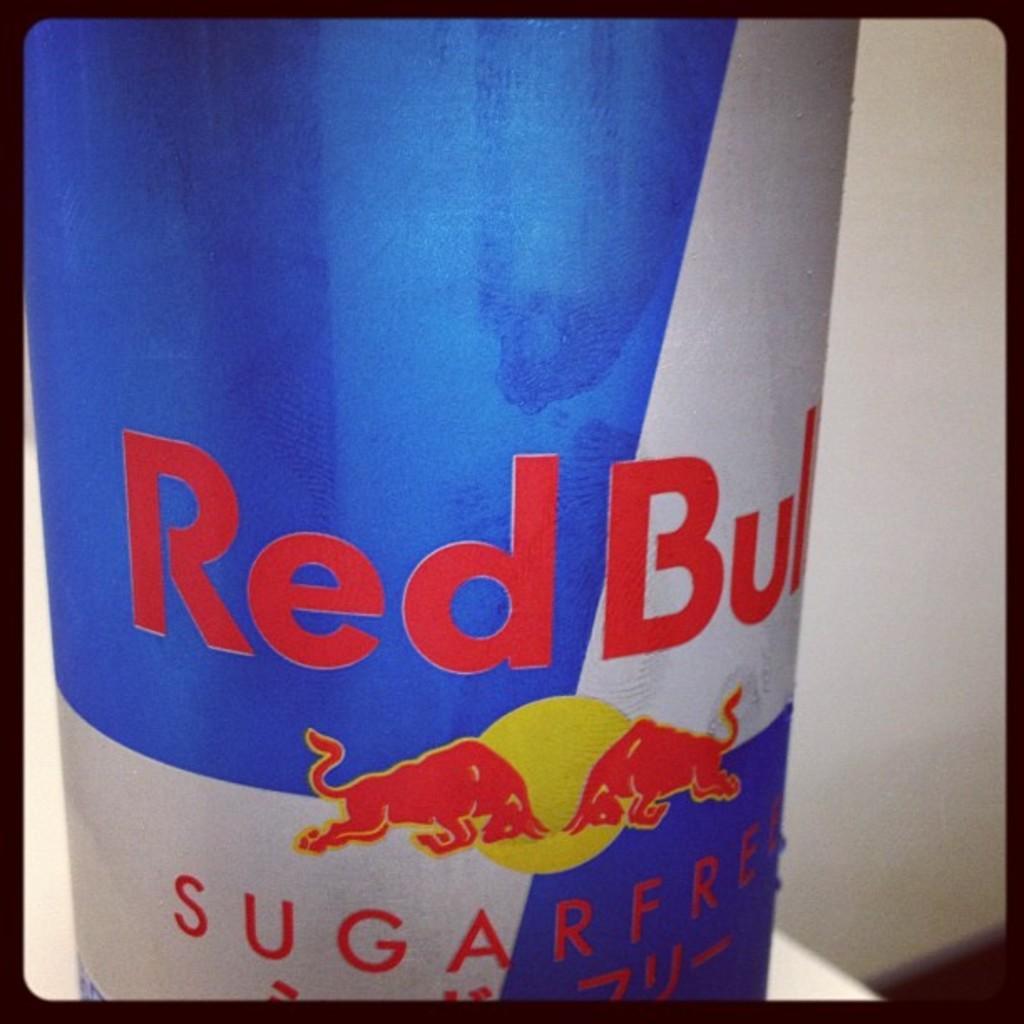Could you give a brief overview of what you see in this image? In this image, we can see blue and white color object. On top of that, we can see some text and figure. On the right side and left side we can see white color. Right side bottom corner, we can see the surface. Here we can see black borders on this image. 